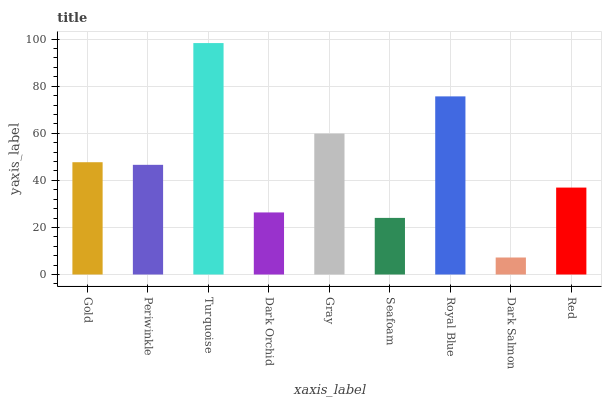Is Dark Salmon the minimum?
Answer yes or no. Yes. Is Turquoise the maximum?
Answer yes or no. Yes. Is Periwinkle the minimum?
Answer yes or no. No. Is Periwinkle the maximum?
Answer yes or no. No. Is Gold greater than Periwinkle?
Answer yes or no. Yes. Is Periwinkle less than Gold?
Answer yes or no. Yes. Is Periwinkle greater than Gold?
Answer yes or no. No. Is Gold less than Periwinkle?
Answer yes or no. No. Is Periwinkle the high median?
Answer yes or no. Yes. Is Periwinkle the low median?
Answer yes or no. Yes. Is Dark Orchid the high median?
Answer yes or no. No. Is Dark Orchid the low median?
Answer yes or no. No. 